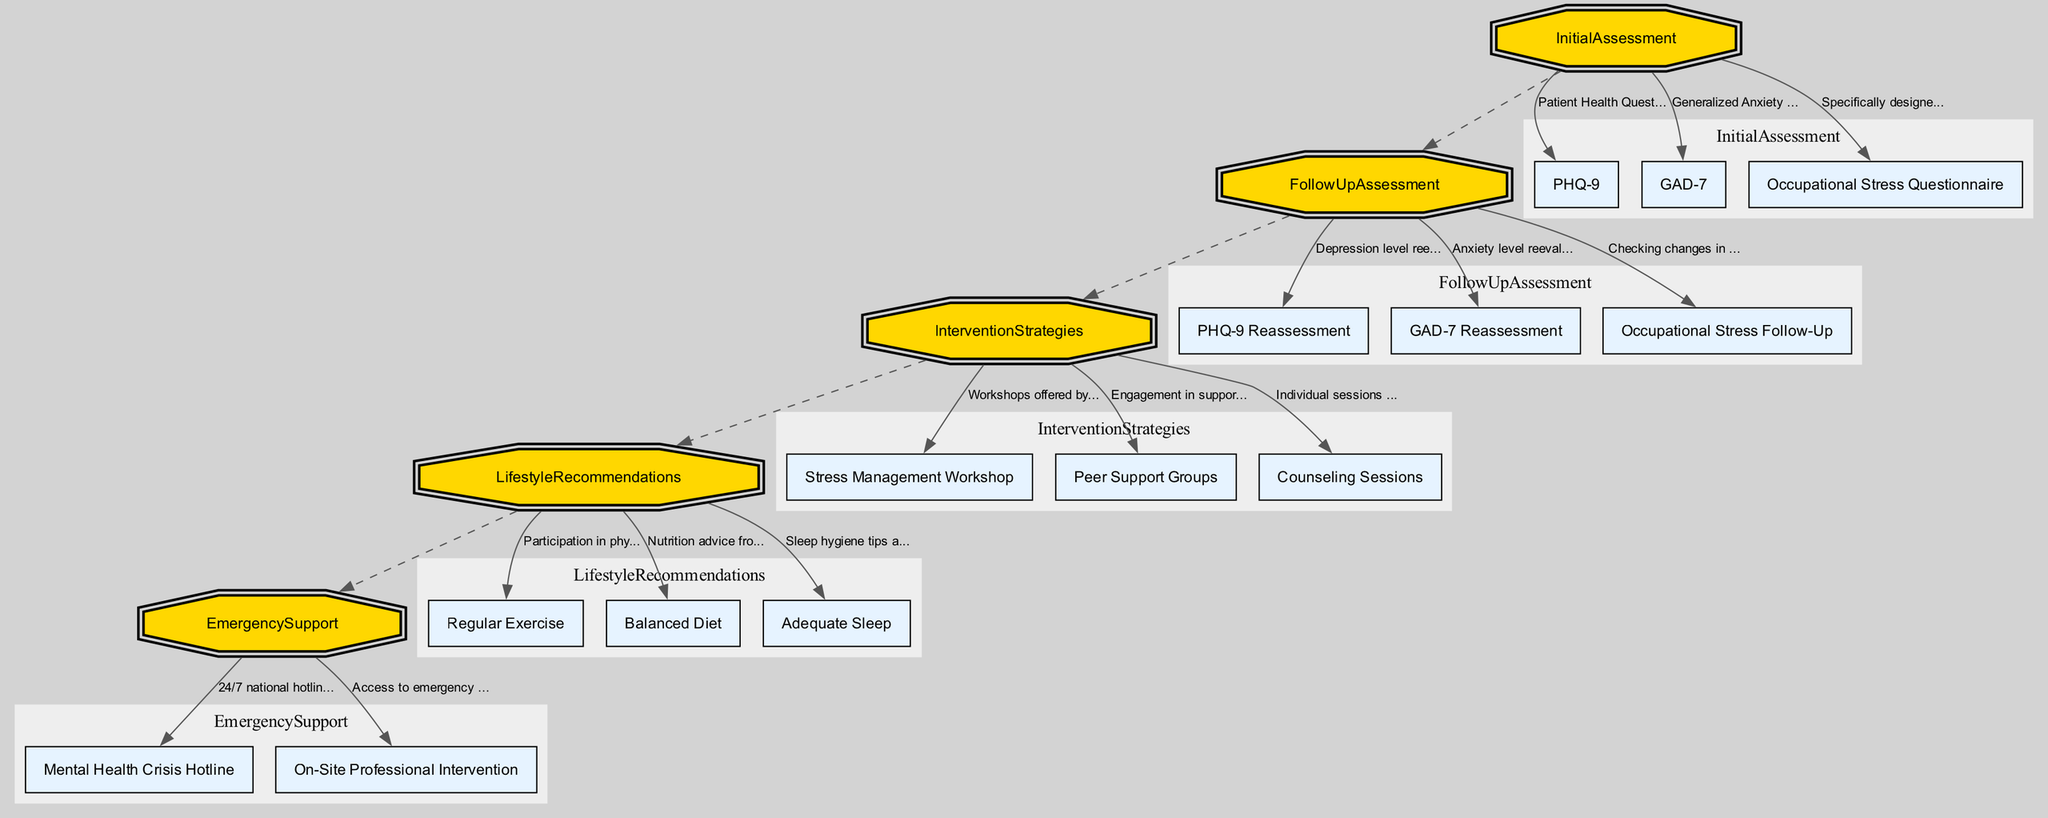What is the first step in the Clinical Pathway? The first step is "Initial Assessment," which involves assessing mental health and stress levels.
Answer: Initial Assessment How often is the Follow-Up Assessment conducted? The Follow-Up Assessment is conducted quarterly, as specified in the node description.
Answer: Quarterly Which component is used for anxiety level reevaluation? The component used for anxiety level reevaluation is the "GAD-7 Reassessment," mentioned in the Follow-Up Assessment.
Answer: GAD-7 Reassessment How many components are listed under Intervention Strategies? There are three components listed under Intervention Strategies: Stress Management Workshop, Peer Support Groups, and Counseling Sessions. Counting those gives us three.
Answer: 3 What emergency support measure is available for immediate assistance? The Mental Health Crisis Hotline is available for immediate assistance during acute mental health crises, as indicated in the Emergency Support section.
Answer: Mental Health Crisis Hotline What is the focus of the Occupational Stress Questionnaire? The Occupational Stress Questionnaire focuses on identifying work-related stressors specifically for professional drivers, as described in the Initial Assessment.
Answer: Work-related stressors What component aims to promote healthier living? The component that aims to promote healthier living is "Lifestyle Recommendations," as described in its respective section in the diagram.
Answer: Lifestyle Recommendations What type of group is encouraged for professional drivers under intervention strategies? Peer Support Groups are encouraged under intervention strategies, allowing engagement among fellow drivers.
Answer: Peer Support Groups What is described as the role of counseling sessions? Counseling Sessions involve individual sessions with mental health professionals, as stated in the Intervention Strategies section.
Answer: Individual sessions with mental health professionals 